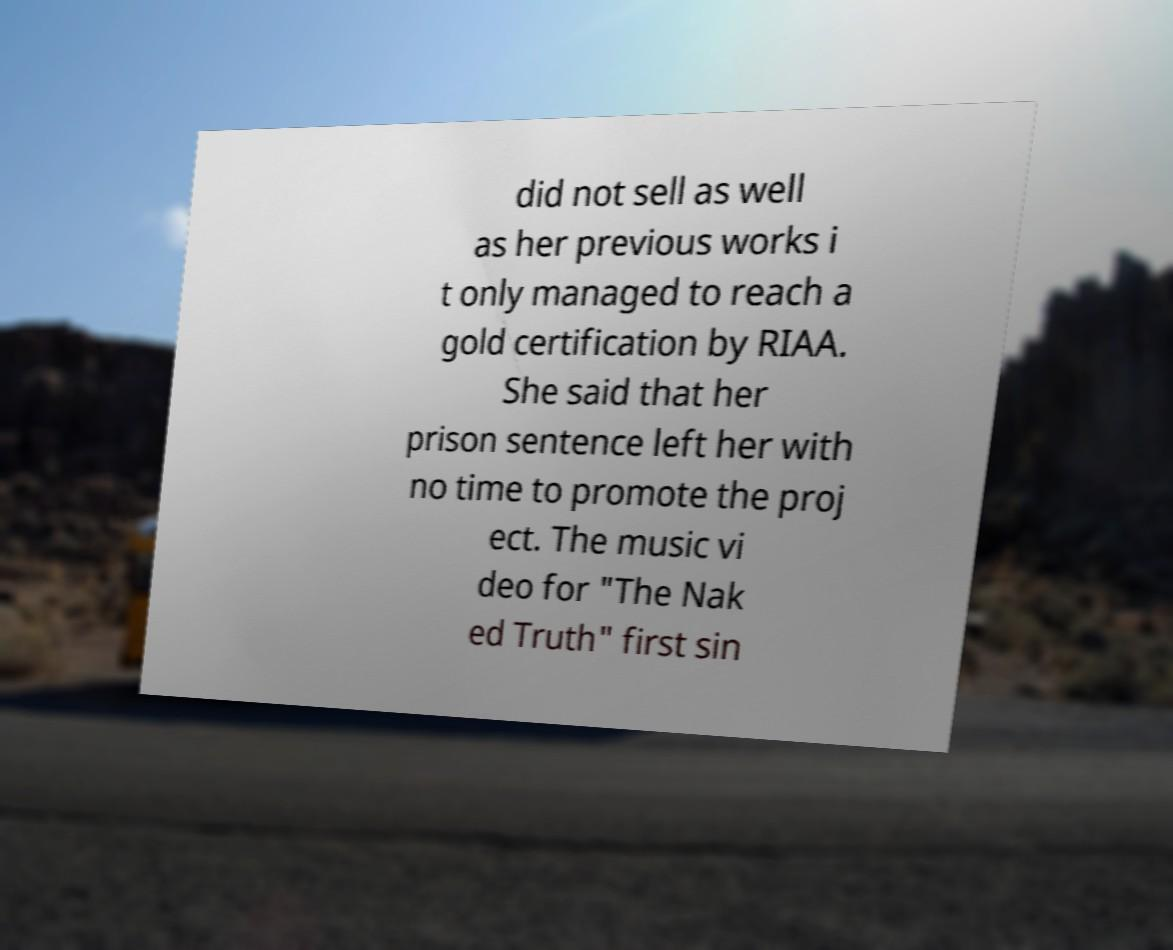What messages or text are displayed in this image? I need them in a readable, typed format. did not sell as well as her previous works i t only managed to reach a gold certification by RIAA. She said that her prison sentence left her with no time to promote the proj ect. The music vi deo for "The Nak ed Truth" first sin 